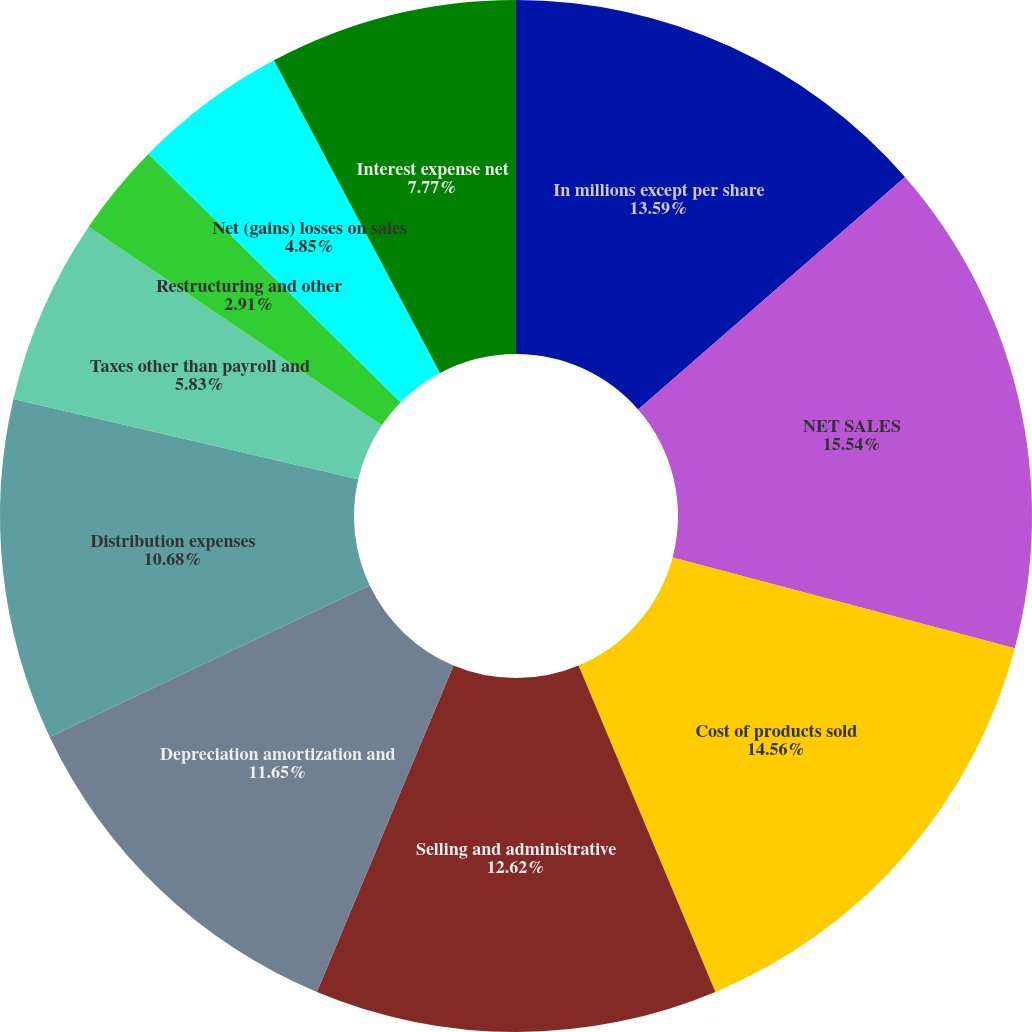Convert chart. <chart><loc_0><loc_0><loc_500><loc_500><pie_chart><fcel>In millions except per share<fcel>NET SALES<fcel>Cost of products sold<fcel>Selling and administrative<fcel>Depreciation amortization and<fcel>Distribution expenses<fcel>Taxes other than payroll and<fcel>Restructuring and other<fcel>Net (gains) losses on sales<fcel>Interest expense net<nl><fcel>13.59%<fcel>15.53%<fcel>14.56%<fcel>12.62%<fcel>11.65%<fcel>10.68%<fcel>5.83%<fcel>2.91%<fcel>4.85%<fcel>7.77%<nl></chart> 